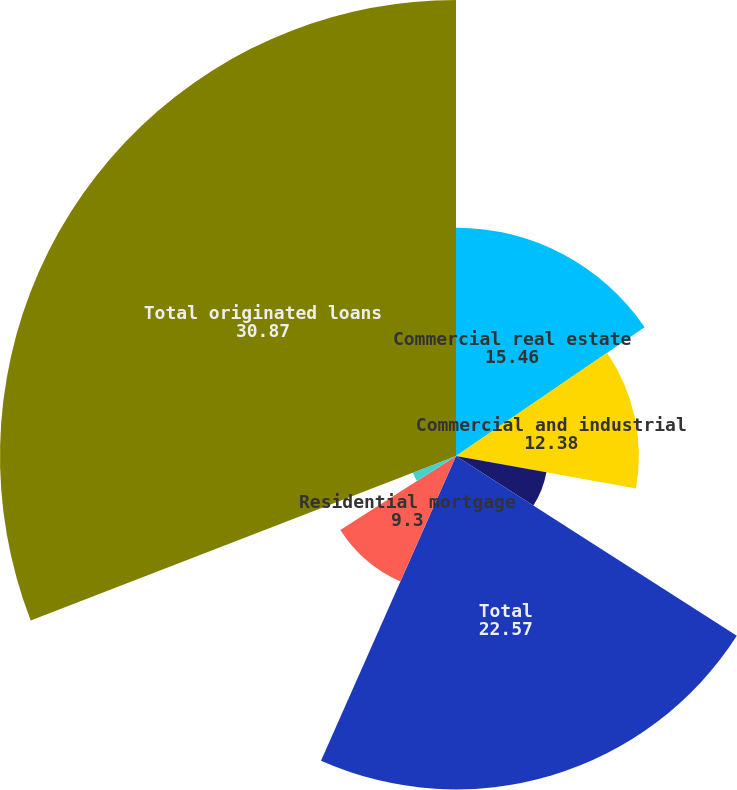Convert chart to OTSL. <chart><loc_0><loc_0><loc_500><loc_500><pie_chart><fcel>Commercial real estate<fcel>Commercial and industrial<fcel>Equipment financing<fcel>Total<fcel>Residential mortgage<fcel>Home equity<fcel>Other consumer<fcel>Total originated loans<nl><fcel>15.46%<fcel>12.38%<fcel>6.22%<fcel>22.57%<fcel>9.3%<fcel>3.14%<fcel>0.05%<fcel>30.87%<nl></chart> 